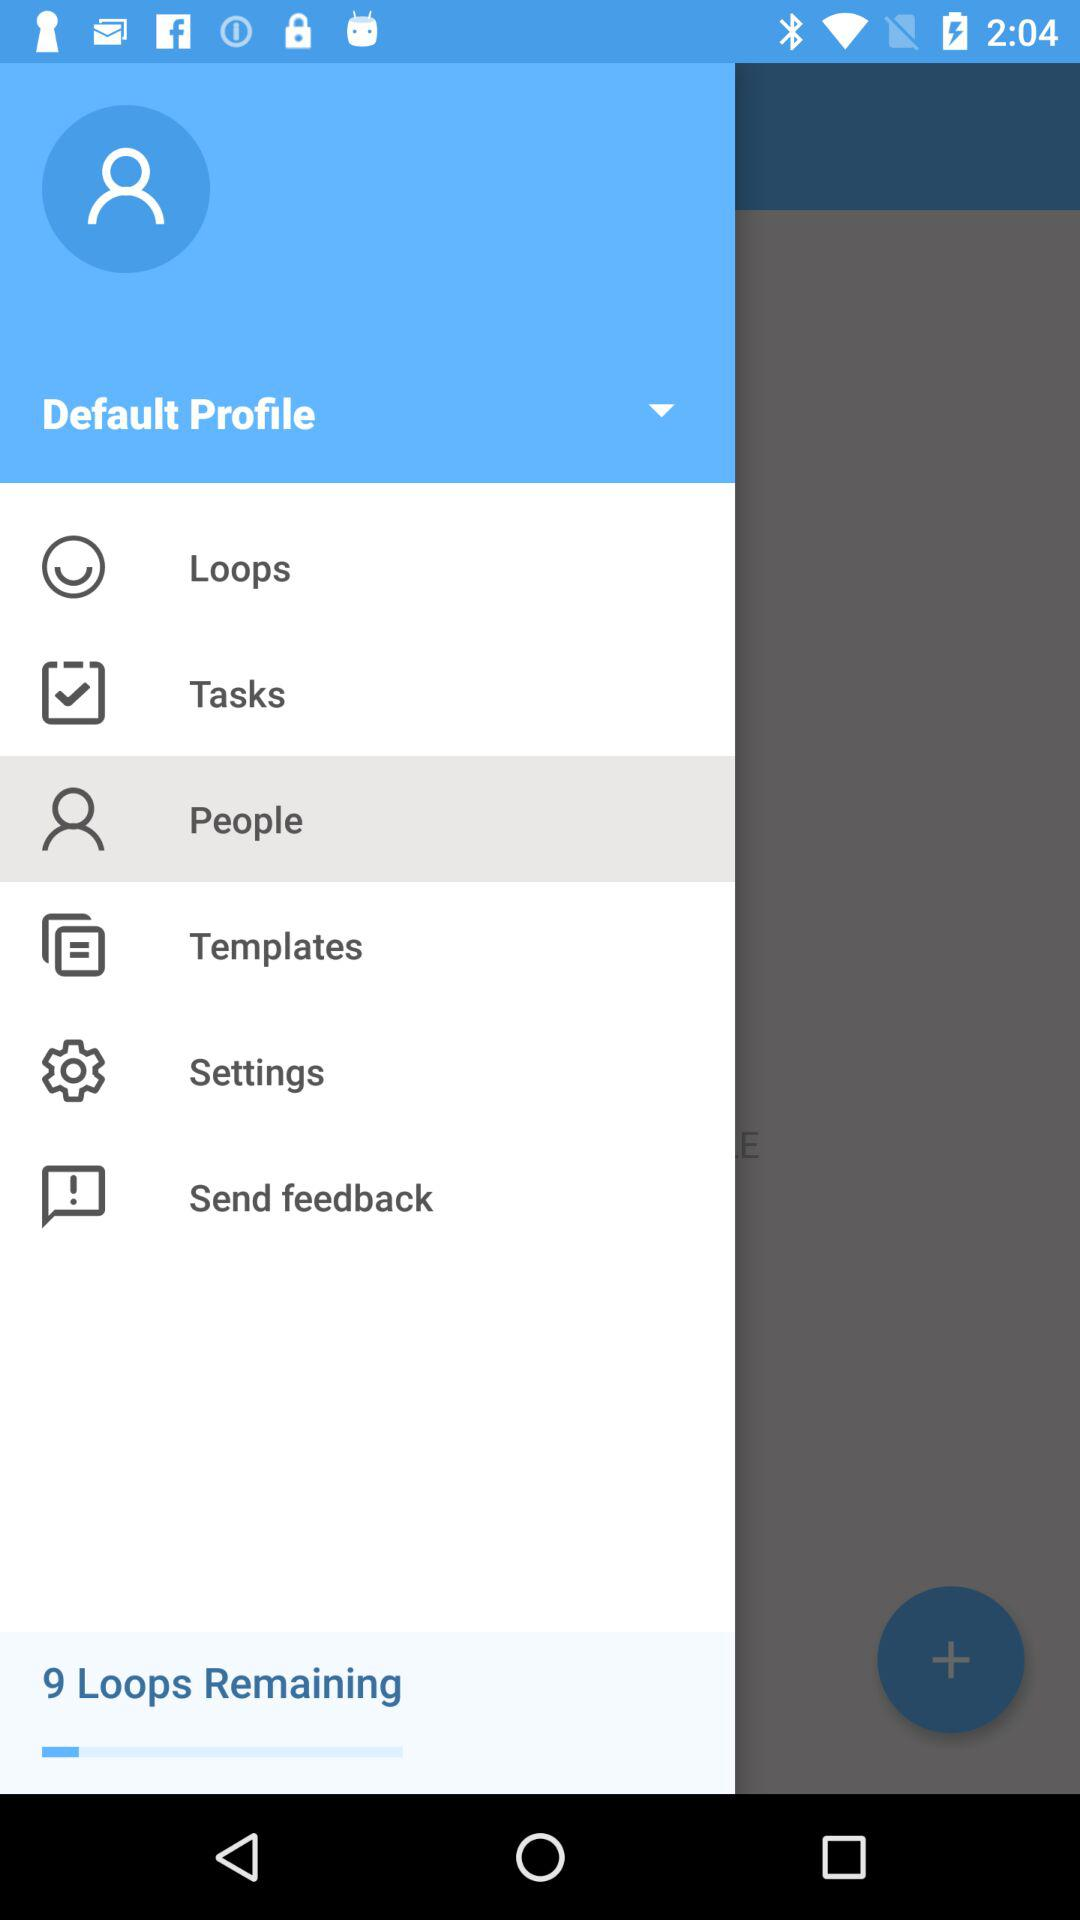Which item is selected? The selected item is "People". 